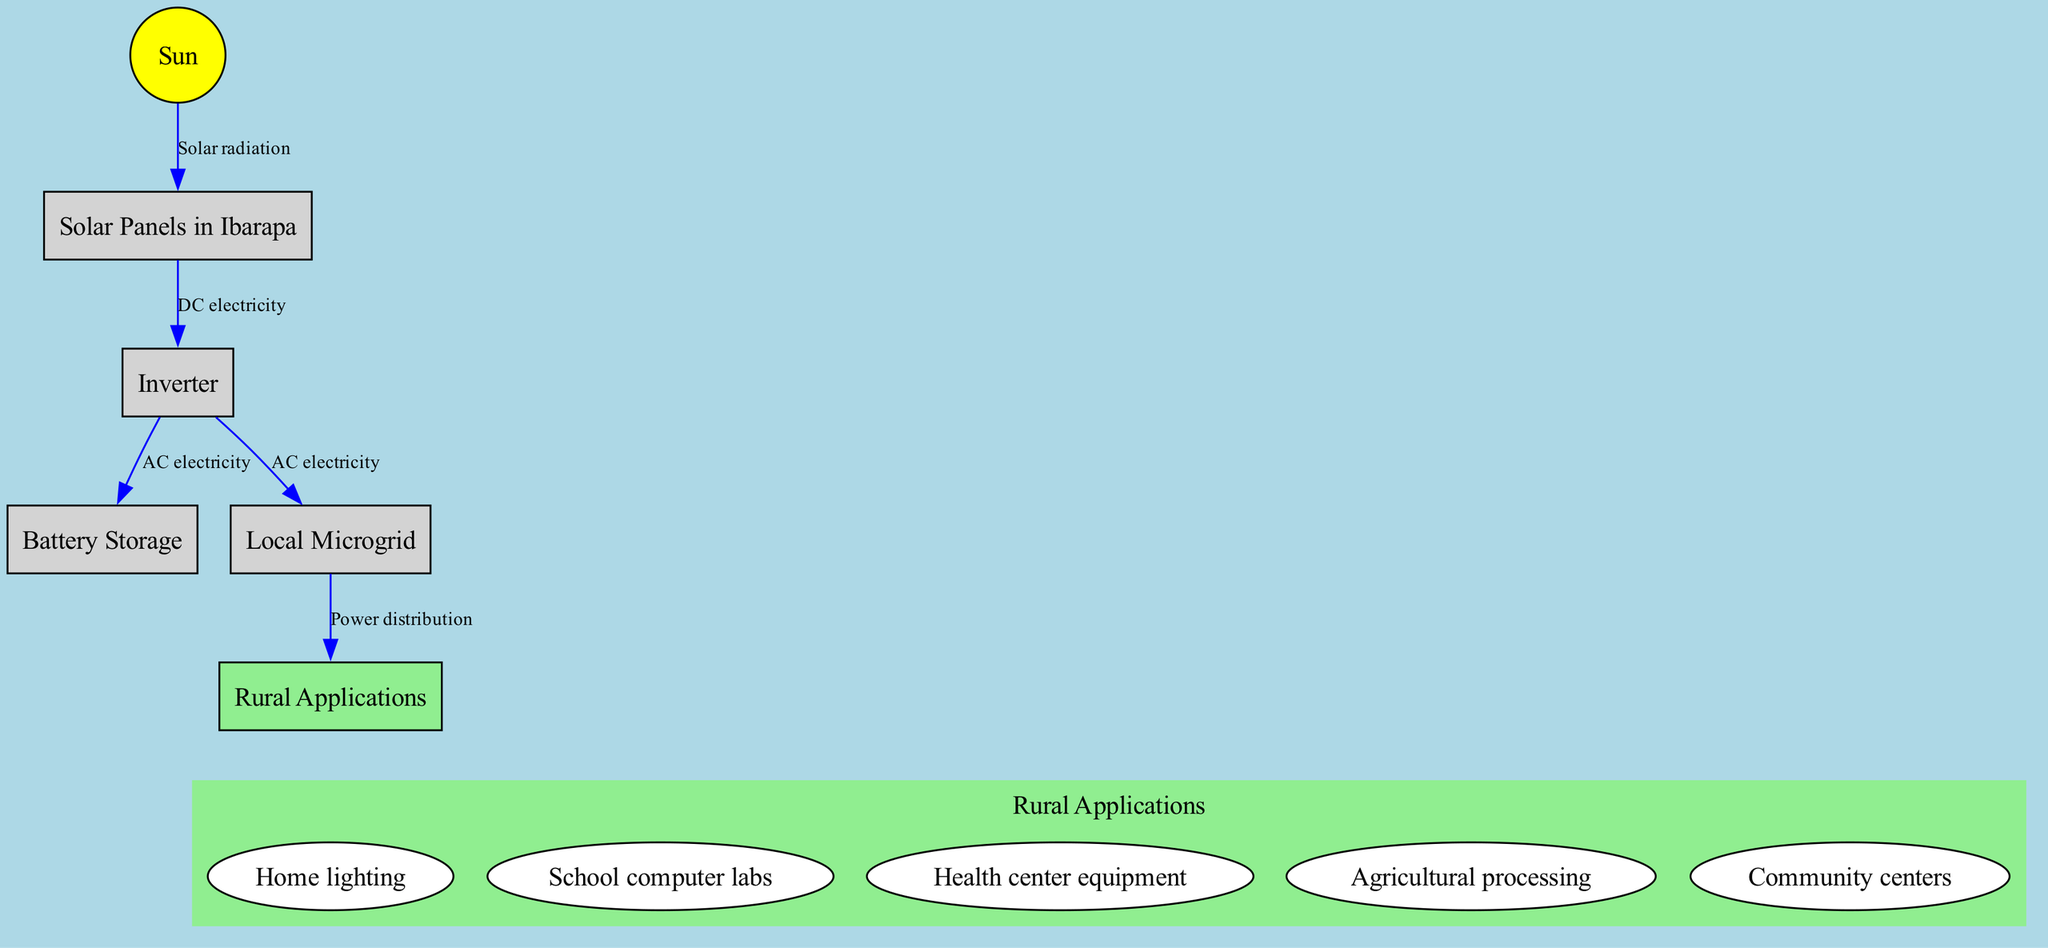What is the first node in the diagram? The first node in the diagram is labeled "Sun." By reviewing the diagram from top to bottom, it appears first, indicating it is the initial source in the process of solar energy conversion.
Answer: Sun How many nodes are present in the diagram? The diagram contains six nodes: Sun, Solar Panels in Ibarapa, Inverter, Battery Storage, Local Microgrid, and Rural Applications. Counting them reveals a total of six distinct entities.
Answer: 6 What type of electricity do solar panels convert solar radiation into? The diagram indicates that solar panels convert solar radiation into DC electricity. This is shown by the edge connecting the Sun to the Solar Panels which labels this conversion.
Answer: DC electricity Which node receives AC electricity directly from the inverter? The inverter distributes AC electricity to both the Battery Storage and the Local Microgrid, as represented by the edges leading from the inverter to these two nodes.
Answer: Battery Storage, Local Microgrid What is the last node connected to the Local Microgrid in the power distribution? The last node connected to the Local Microgrid is labeled "Rural Applications." The edge from the Microgrid clearly denotes this relationship indicating the final usage of the electricity.
Answer: Rural Applications How many applications are listed under Rural Applications? The diagram provides a list of five specific applications categorized under Rural Applications. Enumerating these, we find five distinct uses defined in the diagram.
Answer: 5 What is the function of the inverter in this diagram? The inverter's function in the diagram is to convert DC electricity generated by solar panels into AC electricity. This is captured by the direct connection indicating its role in the energy conversion process.
Answer: Convert DC to AC Which node is the ultimate destination for electricity produced in the diagram? The ultimate destination for the produced electricity is the Rural Applications node. This is indicated by the final edge in the diagram that shows the flow of electricity to various applications.
Answer: Rural Applications 